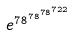Convert formula to latex. <formula><loc_0><loc_0><loc_500><loc_500>e ^ { 7 8 ^ { 7 8 ^ { 7 8 ^ { 7 2 2 } } } }</formula> 